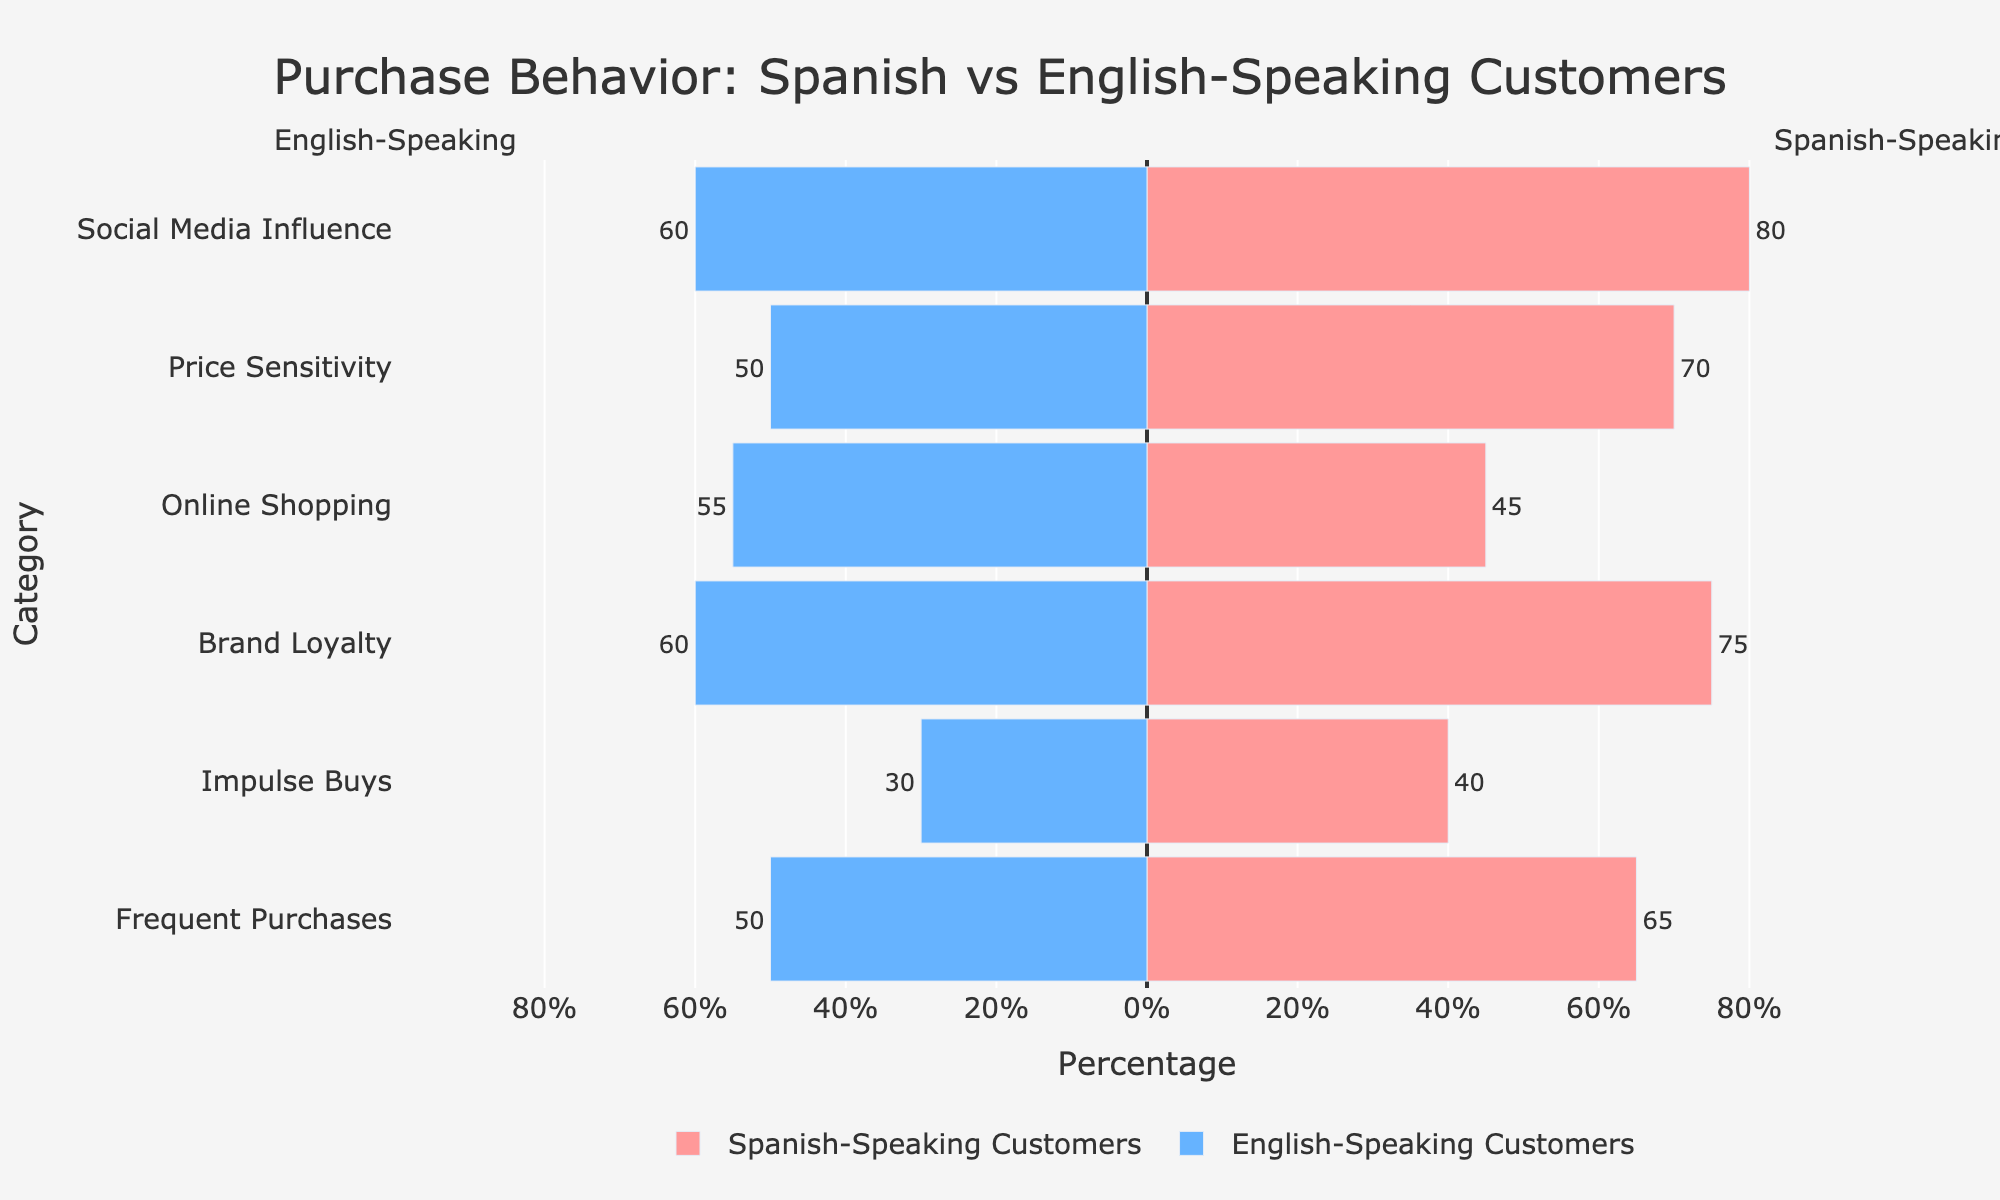What is the percentage difference in frequent purchases between Spanish-speaking and English-speaking customers? To find the percentage difference in frequent purchases, subtract the percentage for English-speaking customers from that of Spanish-speaking customers: 65% - 50%.
Answer: 15% Which customer type is more influenced by social media, and by how much? To determine which customer type is more influenced by social media, compare the percentages: Spanish-speaking customers (80%) vs. English-speaking customers (60%). The difference is 80% - 60%.
Answer: Spanish-speaking customers, by 20% Between online shopping and price sensitivity, which category shows a greater percentage for English-speaking customers? Compare the percentage values for English-speaking customers in both categories: Online Shopping (55%) vs. Price Sensitivity (50%).
Answer: Online shopping What is the combined percentage of Spanish-speaking customers who show brand loyalty and price sensitivity? Add the percentages for Spanish-speaking customers in both categories: Brand Loyalty (75%) + Price Sensitivity (70%).
Answer: 145% How do the figures for impulse buys compare between Spanish-speaking and English-speaking customers? Spanish-speaking customers have a percentage of 40% in impulse buys, while English-speaking customers have 30%.
Answer: Spanish-speaking customers have 10% more What's the percentage difference in the English-speaking customers' online shopping and frequent purchases behavior? Subtract the percentage for frequent purchases from online shopping: 55% - 50%.
Answer: 5% Which category has the smallest difference in behavior between Spanish-speaking and English-speaking customers, and what is the difference? Check differences for each category and find the smallest difference: Frequent Purchases (15%), Impulse Buys (10%), Brand Loyalty (15%), Online Shopping (10%), Price Sensitivity (20%), Social Media Influence (20%).
Answer: Impulse Buys and Online Shopping, 10% In which category do Spanish-speaking customers show the highest percentage, and what is that percentage? Identify the category with the highest percentage for Spanish-speaking customers: Social Media Influence (80%).
Answer: Social Media Influence, 80% What is the range of percentages for English-speaking customers across all categories? Identify the minimum and maximum percentages for English-speaking customers: Minimum (30% from Impulse Buys) and Maximum (60% from Brand Loyalty and Social Media Influence).
Answer: 30% to 60% Which customer type exhibits greater price sensitivity, and by how much? Compare price sensitivity percentages: Spanish-speaking customers (70%) vs. English-speaking customers (50%). The difference is 70% - 50%.
Answer: Spanish-speaking customers, by 20% 